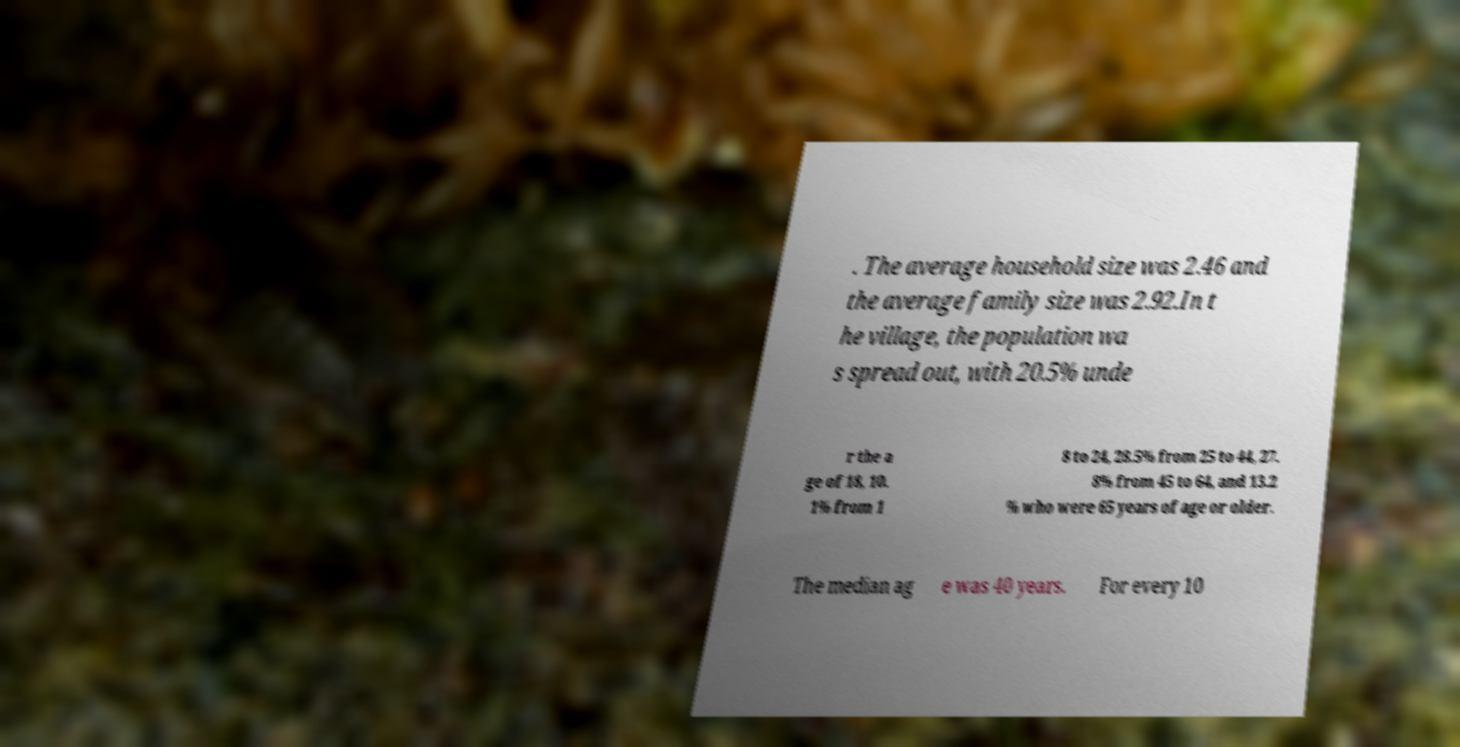Can you accurately transcribe the text from the provided image for me? . The average household size was 2.46 and the average family size was 2.92.In t he village, the population wa s spread out, with 20.5% unde r the a ge of 18, 10. 1% from 1 8 to 24, 28.5% from 25 to 44, 27. 8% from 45 to 64, and 13.2 % who were 65 years of age or older. The median ag e was 40 years. For every 10 